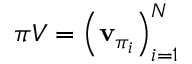<formula> <loc_0><loc_0><loc_500><loc_500>\pi V = \left ( v _ { \pi _ { i } } \right ) _ { i = 1 } ^ { N }</formula> 